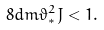<formula> <loc_0><loc_0><loc_500><loc_500>8 d m \vartheta _ { * } ^ { 2 } J < 1 .</formula> 